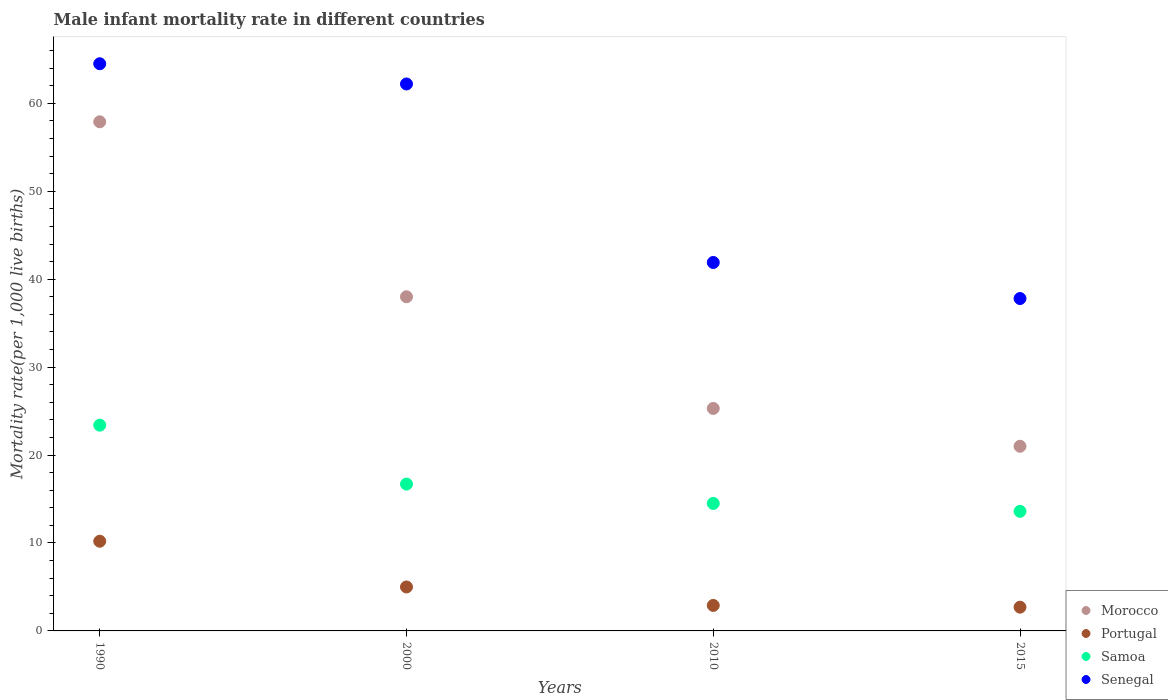Is the number of dotlines equal to the number of legend labels?
Your response must be concise. Yes. What is the male infant mortality rate in Morocco in 2015?
Your answer should be very brief. 21. Across all years, what is the maximum male infant mortality rate in Portugal?
Your answer should be compact. 10.2. Across all years, what is the minimum male infant mortality rate in Morocco?
Ensure brevity in your answer.  21. In which year was the male infant mortality rate in Senegal maximum?
Provide a succinct answer. 1990. In which year was the male infant mortality rate in Senegal minimum?
Give a very brief answer. 2015. What is the total male infant mortality rate in Portugal in the graph?
Provide a short and direct response. 20.8. What is the difference between the male infant mortality rate in Portugal in 1990 and that in 2010?
Keep it short and to the point. 7.3. What is the difference between the male infant mortality rate in Portugal in 2015 and the male infant mortality rate in Morocco in 2010?
Ensure brevity in your answer.  -22.6. What is the average male infant mortality rate in Morocco per year?
Make the answer very short. 35.55. In the year 2010, what is the difference between the male infant mortality rate in Morocco and male infant mortality rate in Samoa?
Offer a very short reply. 10.8. In how many years, is the male infant mortality rate in Portugal greater than 54?
Your answer should be very brief. 0. What is the ratio of the male infant mortality rate in Senegal in 2010 to that in 2015?
Keep it short and to the point. 1.11. Is the difference between the male infant mortality rate in Morocco in 1990 and 2015 greater than the difference between the male infant mortality rate in Samoa in 1990 and 2015?
Provide a succinct answer. Yes. What is the difference between the highest and the second highest male infant mortality rate in Senegal?
Your response must be concise. 2.3. What is the difference between the highest and the lowest male infant mortality rate in Portugal?
Your answer should be compact. 7.5. Is it the case that in every year, the sum of the male infant mortality rate in Morocco and male infant mortality rate in Portugal  is greater than the sum of male infant mortality rate in Samoa and male infant mortality rate in Senegal?
Provide a succinct answer. No. Does the male infant mortality rate in Portugal monotonically increase over the years?
Give a very brief answer. No. Is the male infant mortality rate in Senegal strictly greater than the male infant mortality rate in Portugal over the years?
Offer a very short reply. Yes. Does the graph contain any zero values?
Ensure brevity in your answer.  No. Does the graph contain grids?
Your answer should be compact. No. How many legend labels are there?
Offer a very short reply. 4. How are the legend labels stacked?
Provide a succinct answer. Vertical. What is the title of the graph?
Offer a very short reply. Male infant mortality rate in different countries. Does "Cuba" appear as one of the legend labels in the graph?
Your answer should be very brief. No. What is the label or title of the X-axis?
Your response must be concise. Years. What is the label or title of the Y-axis?
Keep it short and to the point. Mortality rate(per 1,0 live births). What is the Mortality rate(per 1,000 live births) of Morocco in 1990?
Make the answer very short. 57.9. What is the Mortality rate(per 1,000 live births) in Samoa in 1990?
Ensure brevity in your answer.  23.4. What is the Mortality rate(per 1,000 live births) of Senegal in 1990?
Provide a short and direct response. 64.5. What is the Mortality rate(per 1,000 live births) of Portugal in 2000?
Offer a very short reply. 5. What is the Mortality rate(per 1,000 live births) of Senegal in 2000?
Provide a short and direct response. 62.2. What is the Mortality rate(per 1,000 live births) of Morocco in 2010?
Keep it short and to the point. 25.3. What is the Mortality rate(per 1,000 live births) in Samoa in 2010?
Offer a very short reply. 14.5. What is the Mortality rate(per 1,000 live births) in Senegal in 2010?
Offer a terse response. 41.9. What is the Mortality rate(per 1,000 live births) of Morocco in 2015?
Offer a very short reply. 21. What is the Mortality rate(per 1,000 live births) of Senegal in 2015?
Your answer should be very brief. 37.8. Across all years, what is the maximum Mortality rate(per 1,000 live births) of Morocco?
Offer a very short reply. 57.9. Across all years, what is the maximum Mortality rate(per 1,000 live births) of Samoa?
Offer a terse response. 23.4. Across all years, what is the maximum Mortality rate(per 1,000 live births) of Senegal?
Keep it short and to the point. 64.5. Across all years, what is the minimum Mortality rate(per 1,000 live births) of Morocco?
Offer a terse response. 21. Across all years, what is the minimum Mortality rate(per 1,000 live births) of Senegal?
Your answer should be compact. 37.8. What is the total Mortality rate(per 1,000 live births) of Morocco in the graph?
Provide a short and direct response. 142.2. What is the total Mortality rate(per 1,000 live births) in Portugal in the graph?
Offer a very short reply. 20.8. What is the total Mortality rate(per 1,000 live births) of Samoa in the graph?
Give a very brief answer. 68.2. What is the total Mortality rate(per 1,000 live births) of Senegal in the graph?
Provide a succinct answer. 206.4. What is the difference between the Mortality rate(per 1,000 live births) of Senegal in 1990 and that in 2000?
Make the answer very short. 2.3. What is the difference between the Mortality rate(per 1,000 live births) of Morocco in 1990 and that in 2010?
Your response must be concise. 32.6. What is the difference between the Mortality rate(per 1,000 live births) of Senegal in 1990 and that in 2010?
Keep it short and to the point. 22.6. What is the difference between the Mortality rate(per 1,000 live births) in Morocco in 1990 and that in 2015?
Provide a short and direct response. 36.9. What is the difference between the Mortality rate(per 1,000 live births) of Senegal in 1990 and that in 2015?
Your response must be concise. 26.7. What is the difference between the Mortality rate(per 1,000 live births) in Portugal in 2000 and that in 2010?
Your response must be concise. 2.1. What is the difference between the Mortality rate(per 1,000 live births) of Senegal in 2000 and that in 2010?
Your answer should be compact. 20.3. What is the difference between the Mortality rate(per 1,000 live births) of Portugal in 2000 and that in 2015?
Provide a short and direct response. 2.3. What is the difference between the Mortality rate(per 1,000 live births) of Senegal in 2000 and that in 2015?
Keep it short and to the point. 24.4. What is the difference between the Mortality rate(per 1,000 live births) of Portugal in 2010 and that in 2015?
Offer a very short reply. 0.2. What is the difference between the Mortality rate(per 1,000 live births) in Samoa in 2010 and that in 2015?
Offer a very short reply. 0.9. What is the difference between the Mortality rate(per 1,000 live births) of Senegal in 2010 and that in 2015?
Your response must be concise. 4.1. What is the difference between the Mortality rate(per 1,000 live births) in Morocco in 1990 and the Mortality rate(per 1,000 live births) in Portugal in 2000?
Ensure brevity in your answer.  52.9. What is the difference between the Mortality rate(per 1,000 live births) in Morocco in 1990 and the Mortality rate(per 1,000 live births) in Samoa in 2000?
Your answer should be very brief. 41.2. What is the difference between the Mortality rate(per 1,000 live births) in Portugal in 1990 and the Mortality rate(per 1,000 live births) in Samoa in 2000?
Your answer should be compact. -6.5. What is the difference between the Mortality rate(per 1,000 live births) in Portugal in 1990 and the Mortality rate(per 1,000 live births) in Senegal in 2000?
Provide a succinct answer. -52. What is the difference between the Mortality rate(per 1,000 live births) in Samoa in 1990 and the Mortality rate(per 1,000 live births) in Senegal in 2000?
Your answer should be compact. -38.8. What is the difference between the Mortality rate(per 1,000 live births) of Morocco in 1990 and the Mortality rate(per 1,000 live births) of Portugal in 2010?
Keep it short and to the point. 55. What is the difference between the Mortality rate(per 1,000 live births) of Morocco in 1990 and the Mortality rate(per 1,000 live births) of Samoa in 2010?
Make the answer very short. 43.4. What is the difference between the Mortality rate(per 1,000 live births) in Morocco in 1990 and the Mortality rate(per 1,000 live births) in Senegal in 2010?
Give a very brief answer. 16. What is the difference between the Mortality rate(per 1,000 live births) in Portugal in 1990 and the Mortality rate(per 1,000 live births) in Senegal in 2010?
Your answer should be compact. -31.7. What is the difference between the Mortality rate(per 1,000 live births) of Samoa in 1990 and the Mortality rate(per 1,000 live births) of Senegal in 2010?
Give a very brief answer. -18.5. What is the difference between the Mortality rate(per 1,000 live births) in Morocco in 1990 and the Mortality rate(per 1,000 live births) in Portugal in 2015?
Offer a very short reply. 55.2. What is the difference between the Mortality rate(per 1,000 live births) of Morocco in 1990 and the Mortality rate(per 1,000 live births) of Samoa in 2015?
Your answer should be very brief. 44.3. What is the difference between the Mortality rate(per 1,000 live births) in Morocco in 1990 and the Mortality rate(per 1,000 live births) in Senegal in 2015?
Your answer should be very brief. 20.1. What is the difference between the Mortality rate(per 1,000 live births) of Portugal in 1990 and the Mortality rate(per 1,000 live births) of Samoa in 2015?
Provide a succinct answer. -3.4. What is the difference between the Mortality rate(per 1,000 live births) in Portugal in 1990 and the Mortality rate(per 1,000 live births) in Senegal in 2015?
Your answer should be compact. -27.6. What is the difference between the Mortality rate(per 1,000 live births) of Samoa in 1990 and the Mortality rate(per 1,000 live births) of Senegal in 2015?
Ensure brevity in your answer.  -14.4. What is the difference between the Mortality rate(per 1,000 live births) in Morocco in 2000 and the Mortality rate(per 1,000 live births) in Portugal in 2010?
Provide a succinct answer. 35.1. What is the difference between the Mortality rate(per 1,000 live births) of Portugal in 2000 and the Mortality rate(per 1,000 live births) of Senegal in 2010?
Your answer should be compact. -36.9. What is the difference between the Mortality rate(per 1,000 live births) of Samoa in 2000 and the Mortality rate(per 1,000 live births) of Senegal in 2010?
Your answer should be very brief. -25.2. What is the difference between the Mortality rate(per 1,000 live births) of Morocco in 2000 and the Mortality rate(per 1,000 live births) of Portugal in 2015?
Your answer should be very brief. 35.3. What is the difference between the Mortality rate(per 1,000 live births) in Morocco in 2000 and the Mortality rate(per 1,000 live births) in Samoa in 2015?
Your response must be concise. 24.4. What is the difference between the Mortality rate(per 1,000 live births) in Portugal in 2000 and the Mortality rate(per 1,000 live births) in Senegal in 2015?
Make the answer very short. -32.8. What is the difference between the Mortality rate(per 1,000 live births) of Samoa in 2000 and the Mortality rate(per 1,000 live births) of Senegal in 2015?
Your answer should be very brief. -21.1. What is the difference between the Mortality rate(per 1,000 live births) of Morocco in 2010 and the Mortality rate(per 1,000 live births) of Portugal in 2015?
Your answer should be compact. 22.6. What is the difference between the Mortality rate(per 1,000 live births) in Morocco in 2010 and the Mortality rate(per 1,000 live births) in Samoa in 2015?
Your answer should be very brief. 11.7. What is the difference between the Mortality rate(per 1,000 live births) in Portugal in 2010 and the Mortality rate(per 1,000 live births) in Senegal in 2015?
Provide a short and direct response. -34.9. What is the difference between the Mortality rate(per 1,000 live births) in Samoa in 2010 and the Mortality rate(per 1,000 live births) in Senegal in 2015?
Keep it short and to the point. -23.3. What is the average Mortality rate(per 1,000 live births) in Morocco per year?
Give a very brief answer. 35.55. What is the average Mortality rate(per 1,000 live births) in Portugal per year?
Your response must be concise. 5.2. What is the average Mortality rate(per 1,000 live births) in Samoa per year?
Offer a terse response. 17.05. What is the average Mortality rate(per 1,000 live births) of Senegal per year?
Give a very brief answer. 51.6. In the year 1990, what is the difference between the Mortality rate(per 1,000 live births) in Morocco and Mortality rate(per 1,000 live births) in Portugal?
Ensure brevity in your answer.  47.7. In the year 1990, what is the difference between the Mortality rate(per 1,000 live births) in Morocco and Mortality rate(per 1,000 live births) in Samoa?
Offer a terse response. 34.5. In the year 1990, what is the difference between the Mortality rate(per 1,000 live births) of Morocco and Mortality rate(per 1,000 live births) of Senegal?
Give a very brief answer. -6.6. In the year 1990, what is the difference between the Mortality rate(per 1,000 live births) in Portugal and Mortality rate(per 1,000 live births) in Senegal?
Give a very brief answer. -54.3. In the year 1990, what is the difference between the Mortality rate(per 1,000 live births) of Samoa and Mortality rate(per 1,000 live births) of Senegal?
Your answer should be compact. -41.1. In the year 2000, what is the difference between the Mortality rate(per 1,000 live births) of Morocco and Mortality rate(per 1,000 live births) of Samoa?
Make the answer very short. 21.3. In the year 2000, what is the difference between the Mortality rate(per 1,000 live births) of Morocco and Mortality rate(per 1,000 live births) of Senegal?
Your response must be concise. -24.2. In the year 2000, what is the difference between the Mortality rate(per 1,000 live births) of Portugal and Mortality rate(per 1,000 live births) of Senegal?
Give a very brief answer. -57.2. In the year 2000, what is the difference between the Mortality rate(per 1,000 live births) in Samoa and Mortality rate(per 1,000 live births) in Senegal?
Your response must be concise. -45.5. In the year 2010, what is the difference between the Mortality rate(per 1,000 live births) of Morocco and Mortality rate(per 1,000 live births) of Portugal?
Make the answer very short. 22.4. In the year 2010, what is the difference between the Mortality rate(per 1,000 live births) in Morocco and Mortality rate(per 1,000 live births) in Samoa?
Offer a terse response. 10.8. In the year 2010, what is the difference between the Mortality rate(per 1,000 live births) of Morocco and Mortality rate(per 1,000 live births) of Senegal?
Provide a succinct answer. -16.6. In the year 2010, what is the difference between the Mortality rate(per 1,000 live births) in Portugal and Mortality rate(per 1,000 live births) in Senegal?
Offer a terse response. -39. In the year 2010, what is the difference between the Mortality rate(per 1,000 live births) in Samoa and Mortality rate(per 1,000 live births) in Senegal?
Your answer should be very brief. -27.4. In the year 2015, what is the difference between the Mortality rate(per 1,000 live births) in Morocco and Mortality rate(per 1,000 live births) in Portugal?
Offer a terse response. 18.3. In the year 2015, what is the difference between the Mortality rate(per 1,000 live births) of Morocco and Mortality rate(per 1,000 live births) of Senegal?
Your answer should be very brief. -16.8. In the year 2015, what is the difference between the Mortality rate(per 1,000 live births) in Portugal and Mortality rate(per 1,000 live births) in Samoa?
Your response must be concise. -10.9. In the year 2015, what is the difference between the Mortality rate(per 1,000 live births) of Portugal and Mortality rate(per 1,000 live births) of Senegal?
Your answer should be compact. -35.1. In the year 2015, what is the difference between the Mortality rate(per 1,000 live births) of Samoa and Mortality rate(per 1,000 live births) of Senegal?
Provide a succinct answer. -24.2. What is the ratio of the Mortality rate(per 1,000 live births) of Morocco in 1990 to that in 2000?
Your response must be concise. 1.52. What is the ratio of the Mortality rate(per 1,000 live births) of Portugal in 1990 to that in 2000?
Ensure brevity in your answer.  2.04. What is the ratio of the Mortality rate(per 1,000 live births) in Samoa in 1990 to that in 2000?
Provide a succinct answer. 1.4. What is the ratio of the Mortality rate(per 1,000 live births) of Morocco in 1990 to that in 2010?
Offer a very short reply. 2.29. What is the ratio of the Mortality rate(per 1,000 live births) of Portugal in 1990 to that in 2010?
Make the answer very short. 3.52. What is the ratio of the Mortality rate(per 1,000 live births) of Samoa in 1990 to that in 2010?
Your answer should be compact. 1.61. What is the ratio of the Mortality rate(per 1,000 live births) of Senegal in 1990 to that in 2010?
Your answer should be compact. 1.54. What is the ratio of the Mortality rate(per 1,000 live births) in Morocco in 1990 to that in 2015?
Provide a succinct answer. 2.76. What is the ratio of the Mortality rate(per 1,000 live births) of Portugal in 1990 to that in 2015?
Make the answer very short. 3.78. What is the ratio of the Mortality rate(per 1,000 live births) of Samoa in 1990 to that in 2015?
Ensure brevity in your answer.  1.72. What is the ratio of the Mortality rate(per 1,000 live births) of Senegal in 1990 to that in 2015?
Offer a terse response. 1.71. What is the ratio of the Mortality rate(per 1,000 live births) in Morocco in 2000 to that in 2010?
Give a very brief answer. 1.5. What is the ratio of the Mortality rate(per 1,000 live births) of Portugal in 2000 to that in 2010?
Offer a terse response. 1.72. What is the ratio of the Mortality rate(per 1,000 live births) in Samoa in 2000 to that in 2010?
Offer a very short reply. 1.15. What is the ratio of the Mortality rate(per 1,000 live births) in Senegal in 2000 to that in 2010?
Give a very brief answer. 1.48. What is the ratio of the Mortality rate(per 1,000 live births) in Morocco in 2000 to that in 2015?
Provide a succinct answer. 1.81. What is the ratio of the Mortality rate(per 1,000 live births) in Portugal in 2000 to that in 2015?
Provide a succinct answer. 1.85. What is the ratio of the Mortality rate(per 1,000 live births) of Samoa in 2000 to that in 2015?
Offer a very short reply. 1.23. What is the ratio of the Mortality rate(per 1,000 live births) of Senegal in 2000 to that in 2015?
Ensure brevity in your answer.  1.65. What is the ratio of the Mortality rate(per 1,000 live births) of Morocco in 2010 to that in 2015?
Your response must be concise. 1.2. What is the ratio of the Mortality rate(per 1,000 live births) of Portugal in 2010 to that in 2015?
Provide a succinct answer. 1.07. What is the ratio of the Mortality rate(per 1,000 live births) in Samoa in 2010 to that in 2015?
Your response must be concise. 1.07. What is the ratio of the Mortality rate(per 1,000 live births) in Senegal in 2010 to that in 2015?
Your answer should be compact. 1.11. What is the difference between the highest and the second highest Mortality rate(per 1,000 live births) of Morocco?
Offer a very short reply. 19.9. What is the difference between the highest and the second highest Mortality rate(per 1,000 live births) in Senegal?
Your response must be concise. 2.3. What is the difference between the highest and the lowest Mortality rate(per 1,000 live births) of Morocco?
Your response must be concise. 36.9. What is the difference between the highest and the lowest Mortality rate(per 1,000 live births) in Samoa?
Your answer should be compact. 9.8. What is the difference between the highest and the lowest Mortality rate(per 1,000 live births) of Senegal?
Keep it short and to the point. 26.7. 